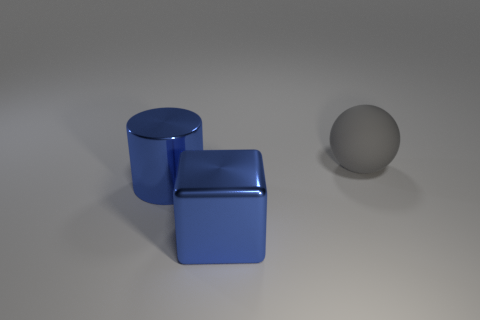What color is the large object that is behind the big object left of the shiny thing that is in front of the large blue cylinder? The large object behind the big blue cube, which is to the left of the shiny sphere in the foreground, appears to be a grey color. 